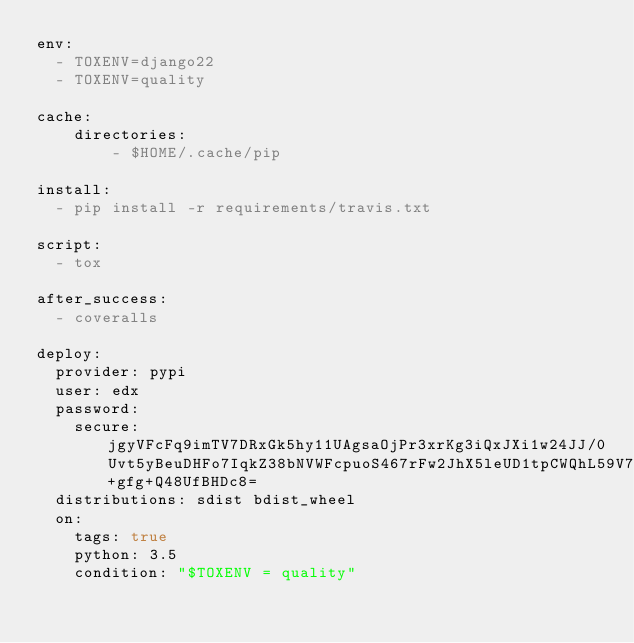Convert code to text. <code><loc_0><loc_0><loc_500><loc_500><_YAML_>env:
  - TOXENV=django22
  - TOXENV=quality

cache:
    directories:
        - $HOME/.cache/pip

install:
  - pip install -r requirements/travis.txt

script:
  - tox

after_success:
  - coveralls

deploy:
  provider: pypi
  user: edx
  password:
    secure: jgyVFcFq9imTV7DRxGk5hy11UAgsaOjPr3xrKg3iQxJXi1w24JJ/0Uvt5yBeuDHFo7IqkZ38bNVWFcpuoS467rFw2JhX5leUD1tpCWQhL59V72Ht5bC5udQ9OGi0tY2HIjpkpUlIh1xYbyKw60iXa4wk7Bt2+gfg+Q48UfBHDc8=
  distributions: sdist bdist_wheel
  on:
    tags: true
    python: 3.5
    condition: "$TOXENV = quality"
</code> 